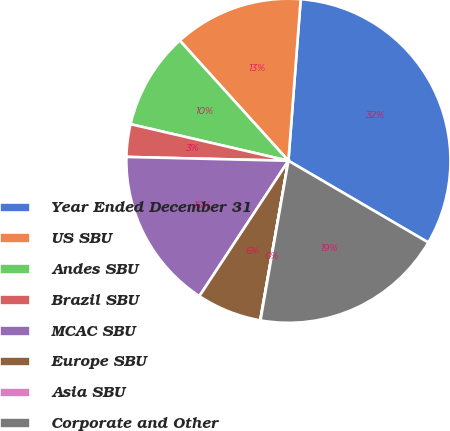Convert chart. <chart><loc_0><loc_0><loc_500><loc_500><pie_chart><fcel>Year Ended December 31<fcel>US SBU<fcel>Andes SBU<fcel>Brazil SBU<fcel>MCAC SBU<fcel>Europe SBU<fcel>Asia SBU<fcel>Corporate and Other<nl><fcel>32.21%<fcel>12.9%<fcel>9.68%<fcel>3.25%<fcel>16.12%<fcel>6.47%<fcel>0.03%<fcel>19.34%<nl></chart> 